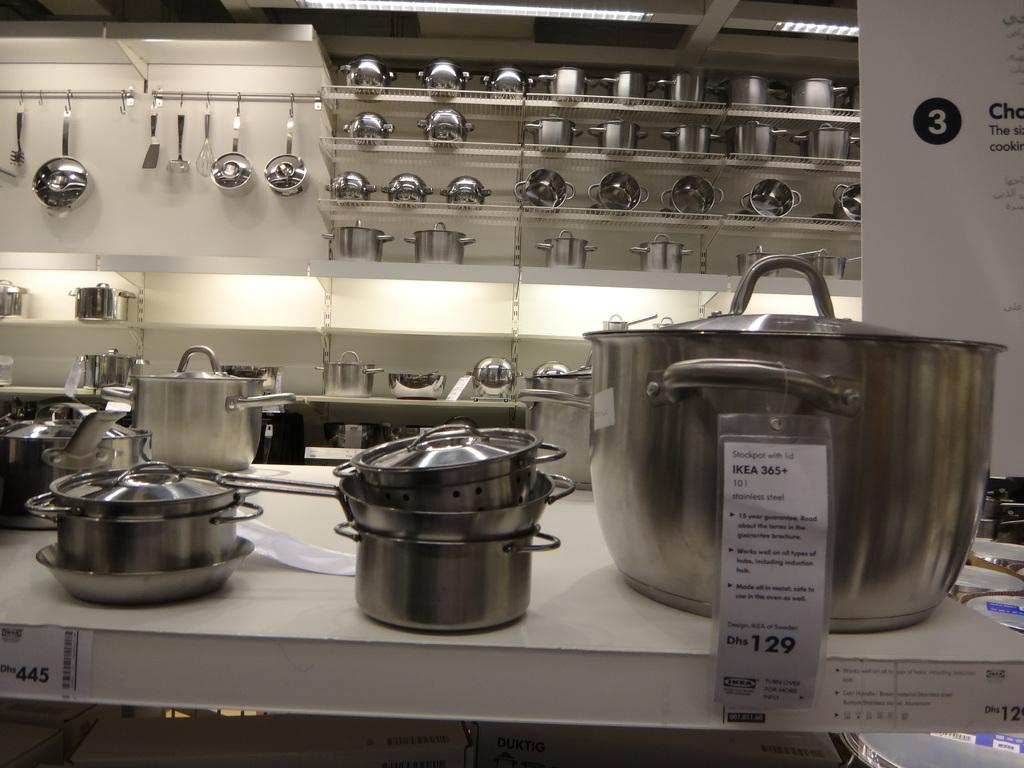<image>
Summarize the visual content of the image. pots for sale at IKEA 356+ for the price of Dhs 129 